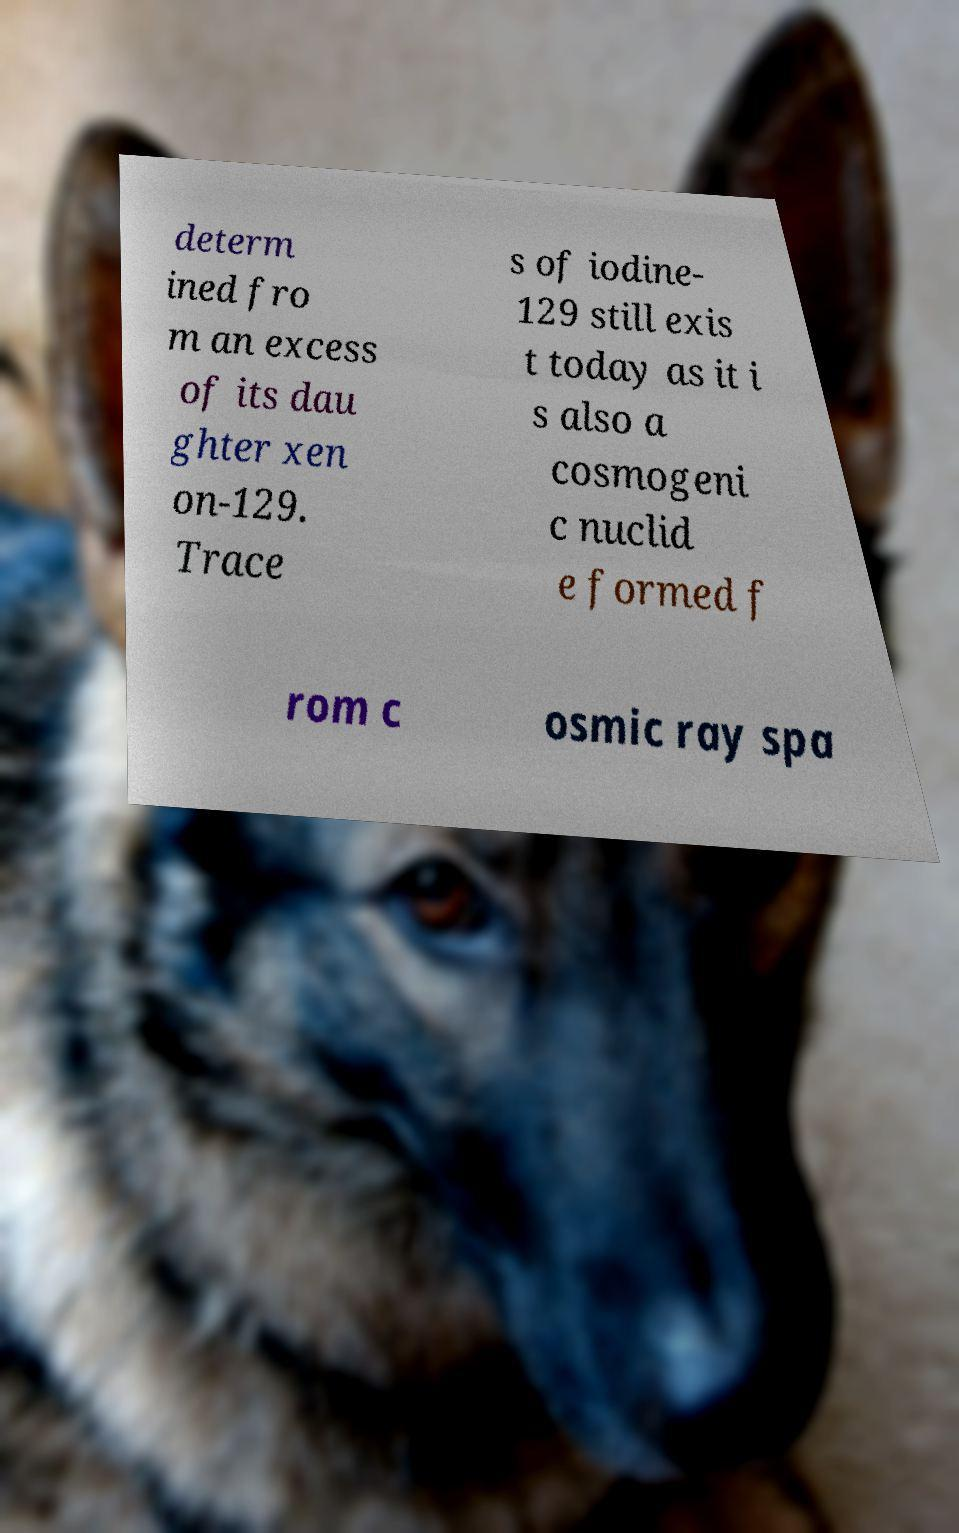There's text embedded in this image that I need extracted. Can you transcribe it verbatim? determ ined fro m an excess of its dau ghter xen on-129. Trace s of iodine- 129 still exis t today as it i s also a cosmogeni c nuclid e formed f rom c osmic ray spa 